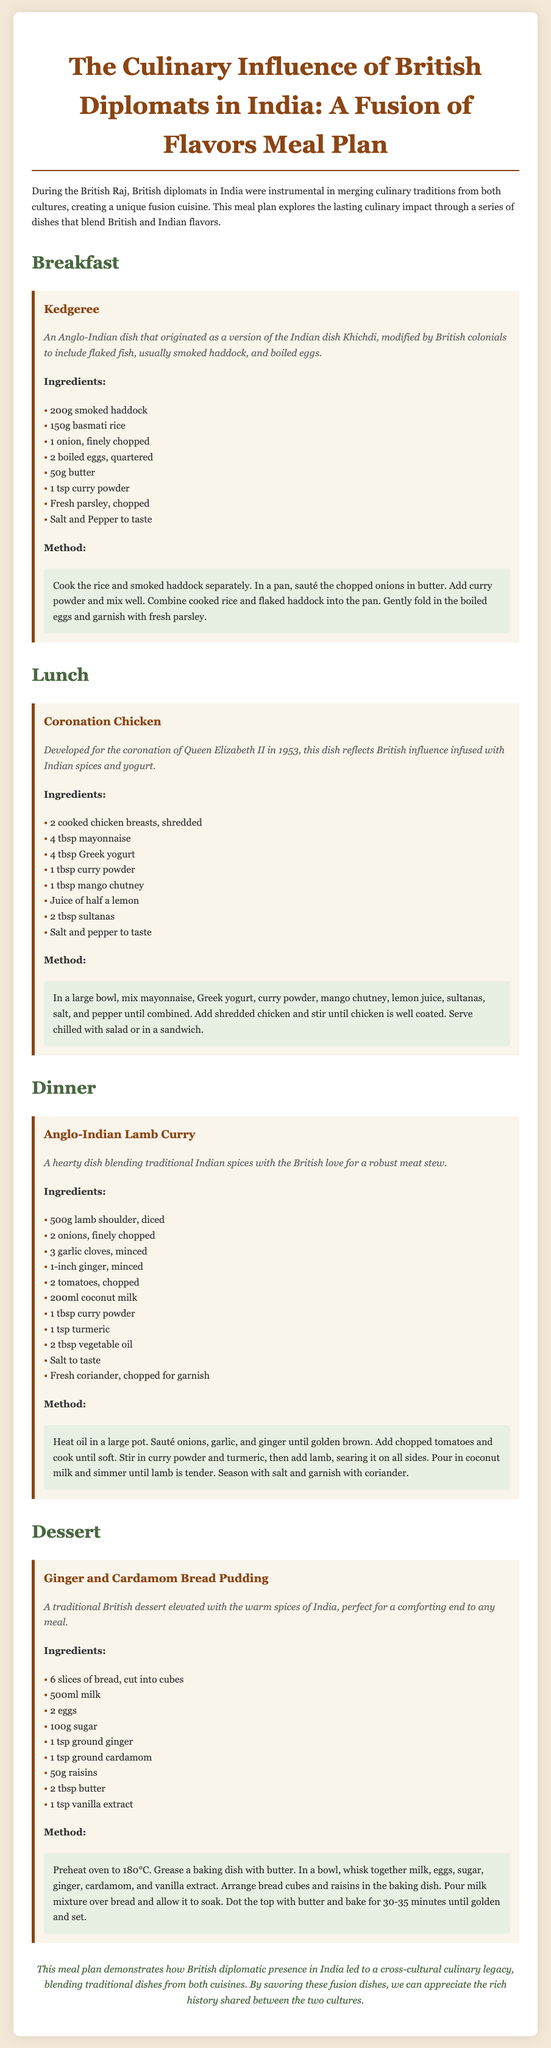What is the name of the breakfast dish? The breakfast dish mentioned in the meal plan is Kedgeree.
Answer: Kedgeree How many eggs are used in Kedgeree? The meal plan specifies that 2 boiled eggs are used in Kedgeree.
Answer: 2 What key ingredient differentiates Coronation Chicken from other chicken salads? Coronation Chicken is differentiated by the inclusion of curry powder and mango chutney.
Answer: Curry powder and mango chutney What is the main protein in Anglo-Indian Lamb Curry? The main protein in Anglo-Indian Lamb Curry is lamb shoulder.
Answer: Lamb shoulder How long should the Ginger and Cardamom Bread Pudding be baked? The baking time specified in the meal plan is 30-35 minutes.
Answer: 30-35 minutes What cuisine does the meal plan focus on blending? The meal plan focuses on blending British and Indian cuisines.
Answer: British and Indian What role did British diplomats play in the culinary aspect in India? British diplomats were instrumental in merging culinary traditions from both cultures.
Answer: Merging culinary traditions What is the first dish listed in the meal plan? The first dish listed in the meal plan is Kedgeree.
Answer: Kedgeree 